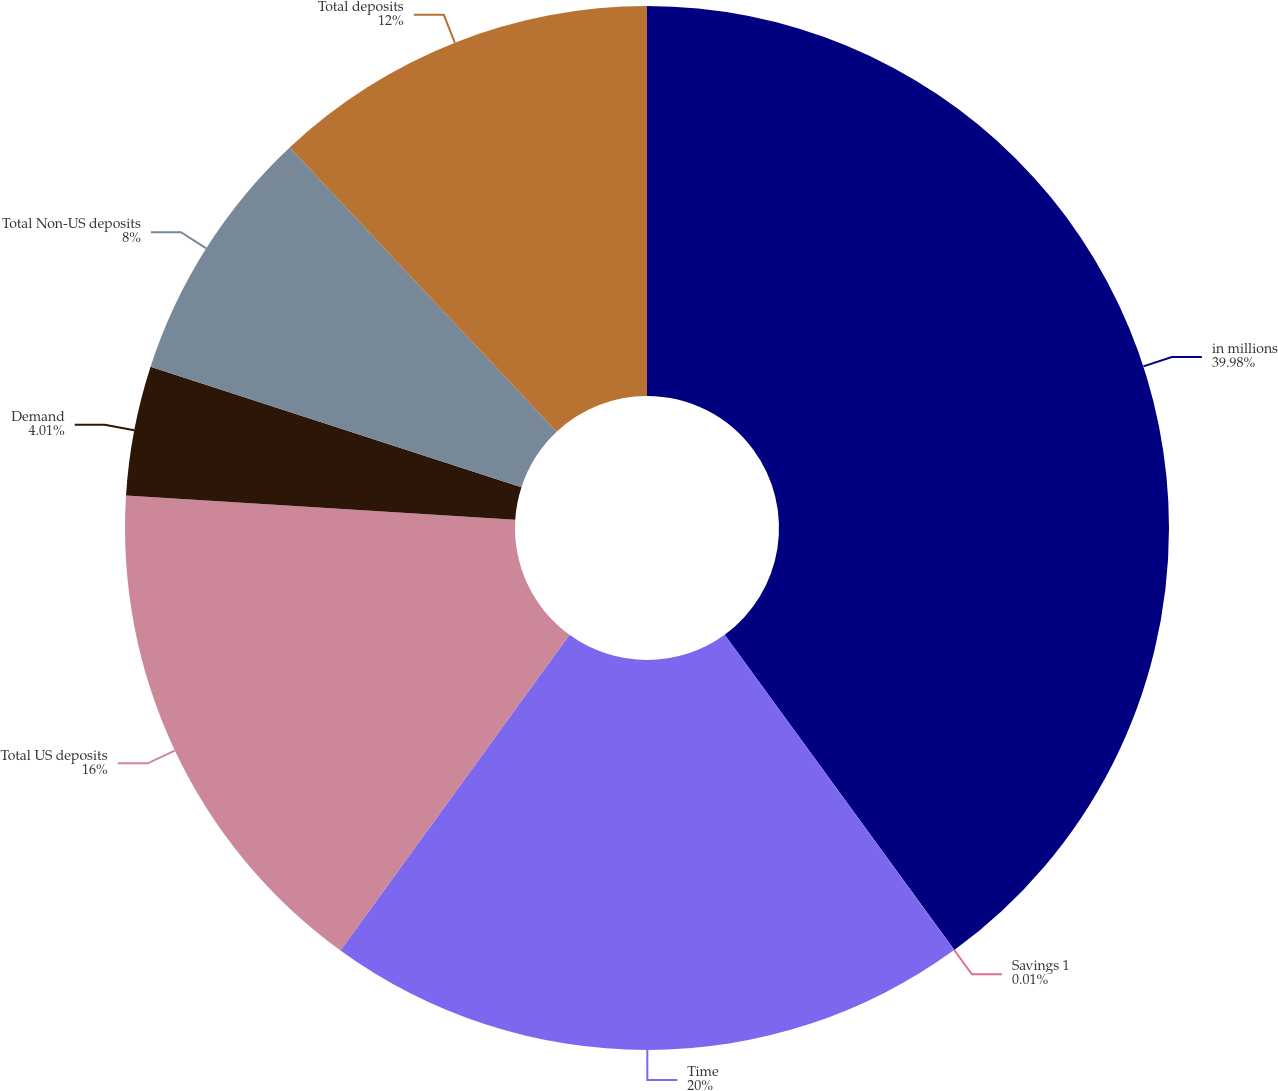<chart> <loc_0><loc_0><loc_500><loc_500><pie_chart><fcel>in millions<fcel>Savings 1<fcel>Time<fcel>Total US deposits<fcel>Demand<fcel>Total Non-US deposits<fcel>Total deposits<nl><fcel>39.98%<fcel>0.01%<fcel>20.0%<fcel>16.0%<fcel>4.01%<fcel>8.0%<fcel>12.0%<nl></chart> 